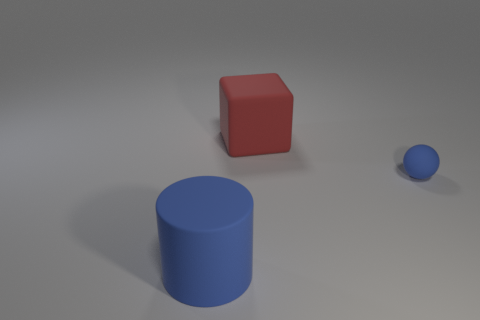What is the shape of the big thing that is the same color as the tiny rubber sphere?
Your answer should be compact. Cylinder. What is the size of the rubber cylinder that is the same color as the tiny thing?
Make the answer very short. Large. Is there a big cylinder that has the same color as the tiny sphere?
Provide a short and direct response. Yes. Does the tiny matte ball have the same color as the thing that is in front of the ball?
Your answer should be compact. Yes. Is the number of large rubber cylinders greater than the number of cyan metallic things?
Provide a short and direct response. Yes. Is there any other thing that is the same color as the cylinder?
Your answer should be compact. Yes. What number of other objects are the same size as the blue ball?
Provide a short and direct response. 0. There is a blue sphere behind the blue rubber object in front of the blue matte object behind the big blue cylinder; what is it made of?
Make the answer very short. Rubber. Is the material of the sphere the same as the blue object left of the rubber cube?
Provide a succinct answer. Yes. Are there fewer rubber cylinders on the right side of the tiny matte ball than large rubber things that are behind the blue cylinder?
Ensure brevity in your answer.  Yes. 